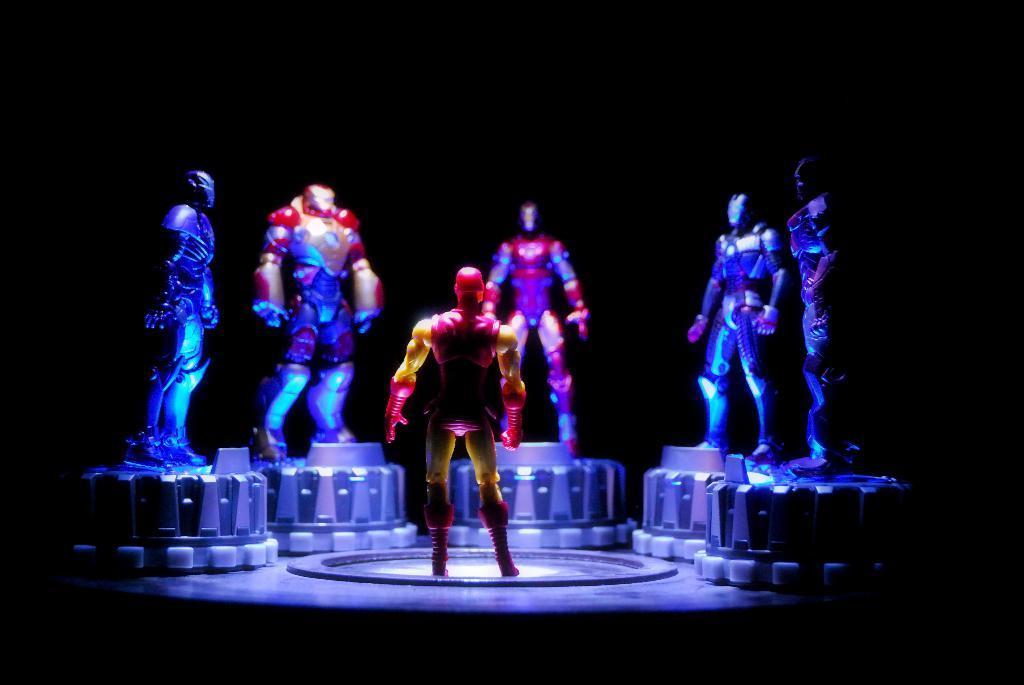Please provide a concise description of this image. In this image we can see few toys. There is a dark background in the image. 